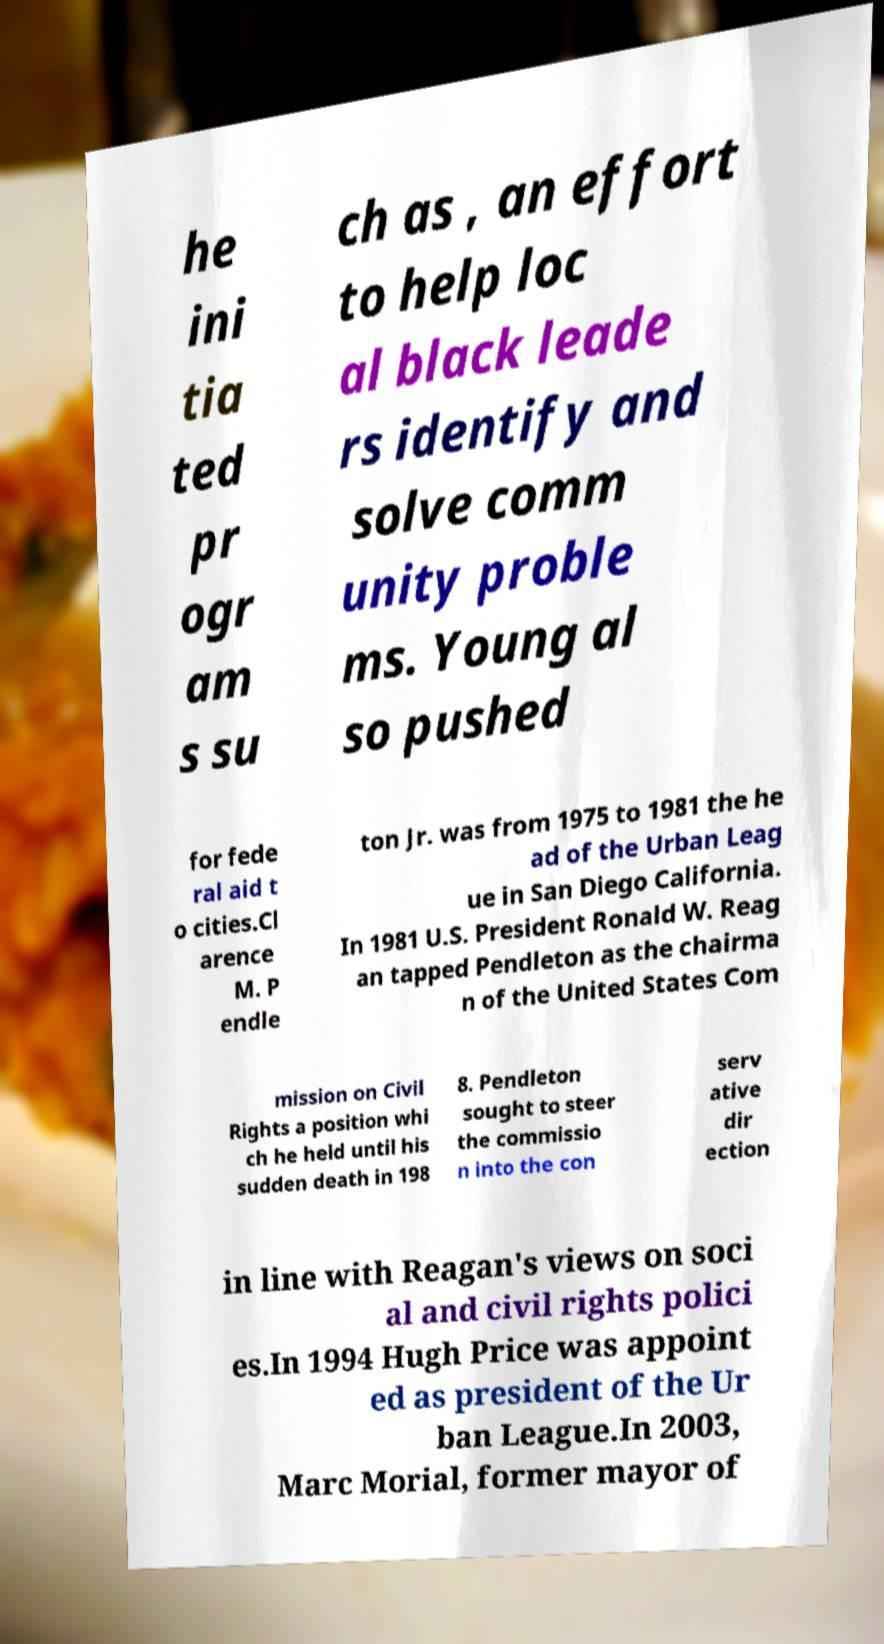There's text embedded in this image that I need extracted. Can you transcribe it verbatim? he ini tia ted pr ogr am s su ch as , an effort to help loc al black leade rs identify and solve comm unity proble ms. Young al so pushed for fede ral aid t o cities.Cl arence M. P endle ton Jr. was from 1975 to 1981 the he ad of the Urban Leag ue in San Diego California. In 1981 U.S. President Ronald W. Reag an tapped Pendleton as the chairma n of the United States Com mission on Civil Rights a position whi ch he held until his sudden death in 198 8. Pendleton sought to steer the commissio n into the con serv ative dir ection in line with Reagan's views on soci al and civil rights polici es.In 1994 Hugh Price was appoint ed as president of the Ur ban League.In 2003, Marc Morial, former mayor of 